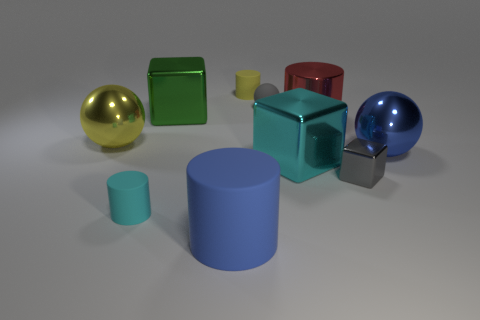Which objects are reflective? The gold, green, red, and blue spheres, along with the gray cylinder and cube, exhibit reflective properties. 